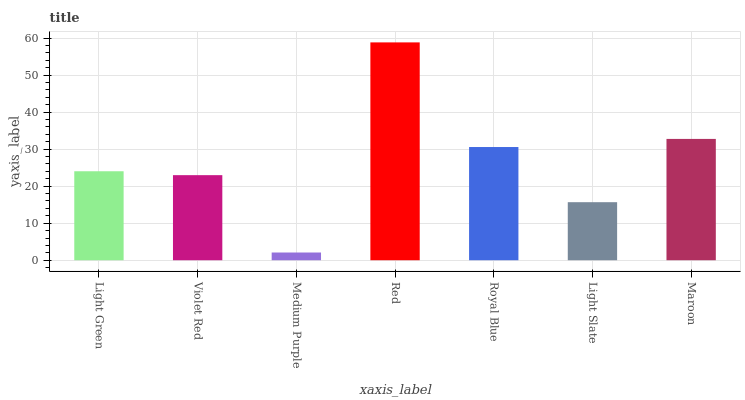Is Medium Purple the minimum?
Answer yes or no. Yes. Is Red the maximum?
Answer yes or no. Yes. Is Violet Red the minimum?
Answer yes or no. No. Is Violet Red the maximum?
Answer yes or no. No. Is Light Green greater than Violet Red?
Answer yes or no. Yes. Is Violet Red less than Light Green?
Answer yes or no. Yes. Is Violet Red greater than Light Green?
Answer yes or no. No. Is Light Green less than Violet Red?
Answer yes or no. No. Is Light Green the high median?
Answer yes or no. Yes. Is Light Green the low median?
Answer yes or no. Yes. Is Violet Red the high median?
Answer yes or no. No. Is Light Slate the low median?
Answer yes or no. No. 